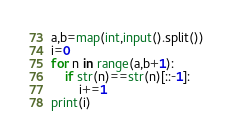Convert code to text. <code><loc_0><loc_0><loc_500><loc_500><_Python_>a,b=map(int,input().split())
i=0
for n in range(a,b+1):
    if str(n)==str(n)[::-1]:
        i+=1
print(i)</code> 